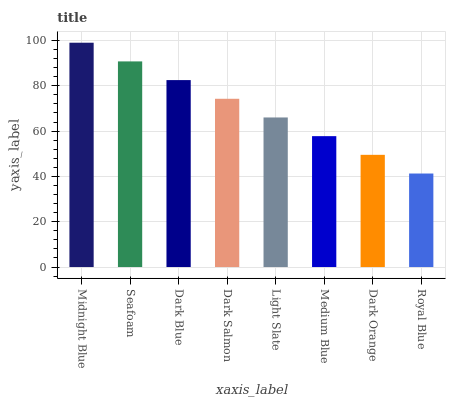Is Royal Blue the minimum?
Answer yes or no. Yes. Is Midnight Blue the maximum?
Answer yes or no. Yes. Is Seafoam the minimum?
Answer yes or no. No. Is Seafoam the maximum?
Answer yes or no. No. Is Midnight Blue greater than Seafoam?
Answer yes or no. Yes. Is Seafoam less than Midnight Blue?
Answer yes or no. Yes. Is Seafoam greater than Midnight Blue?
Answer yes or no. No. Is Midnight Blue less than Seafoam?
Answer yes or no. No. Is Dark Salmon the high median?
Answer yes or no. Yes. Is Light Slate the low median?
Answer yes or no. Yes. Is Dark Orange the high median?
Answer yes or no. No. Is Dark Orange the low median?
Answer yes or no. No. 